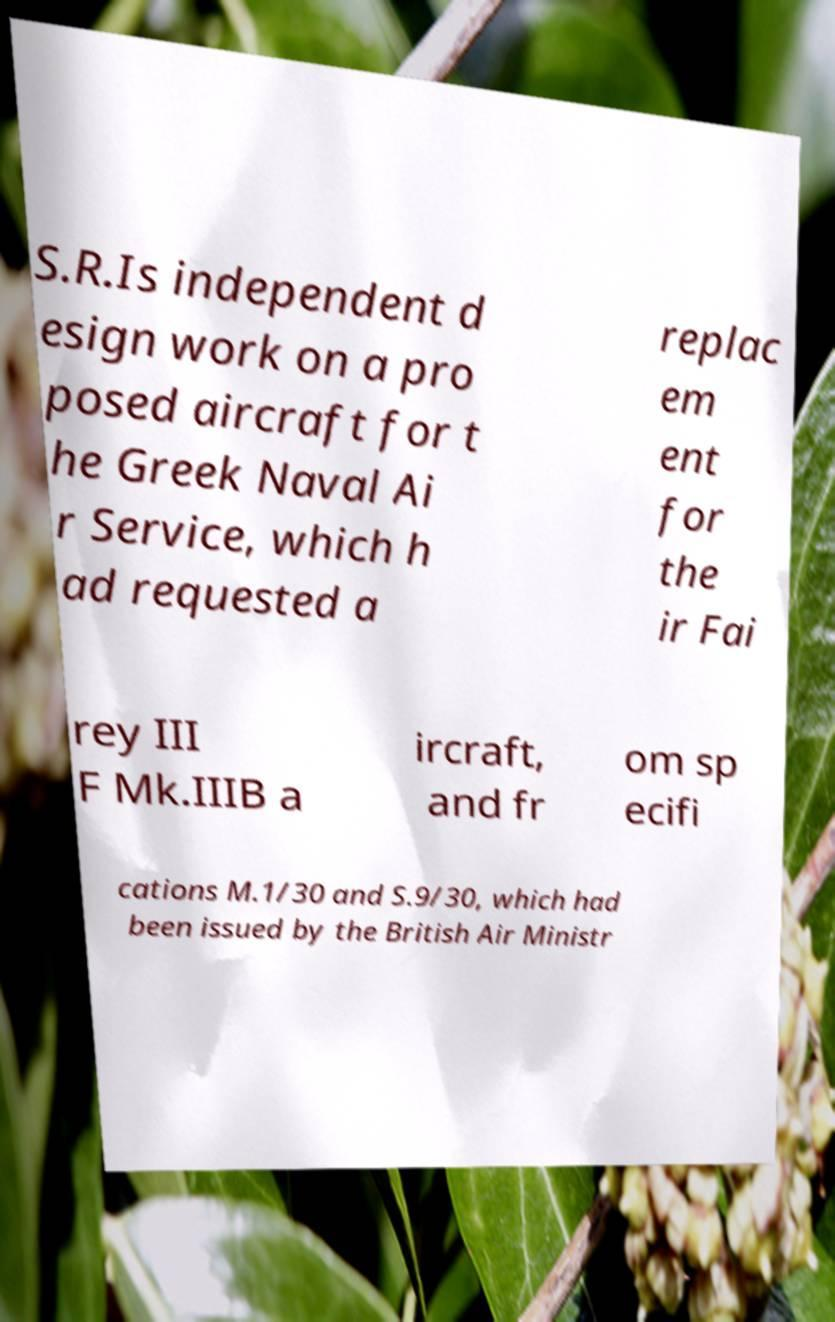Please read and relay the text visible in this image. What does it say? S.R.Is independent d esign work on a pro posed aircraft for t he Greek Naval Ai r Service, which h ad requested a replac em ent for the ir Fai rey III F Mk.IIIB a ircraft, and fr om sp ecifi cations M.1/30 and S.9/30, which had been issued by the British Air Ministr 